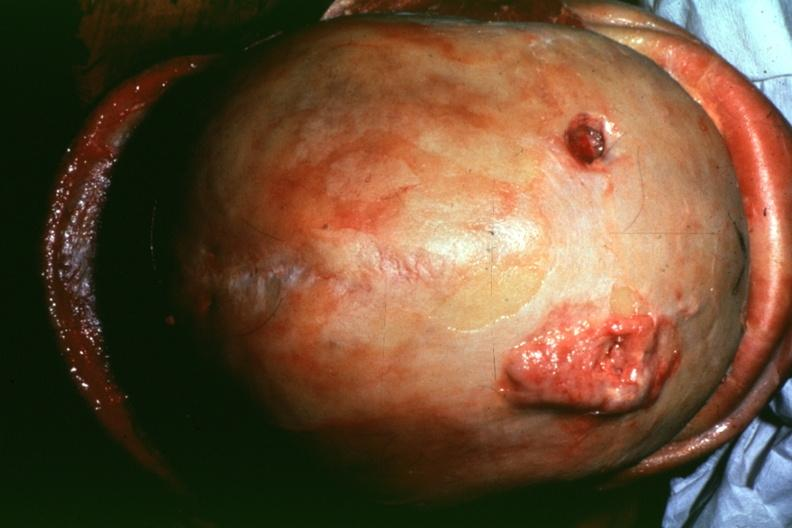what does this image show?
Answer the question using a single word or phrase. Dr garcia tumors b4 